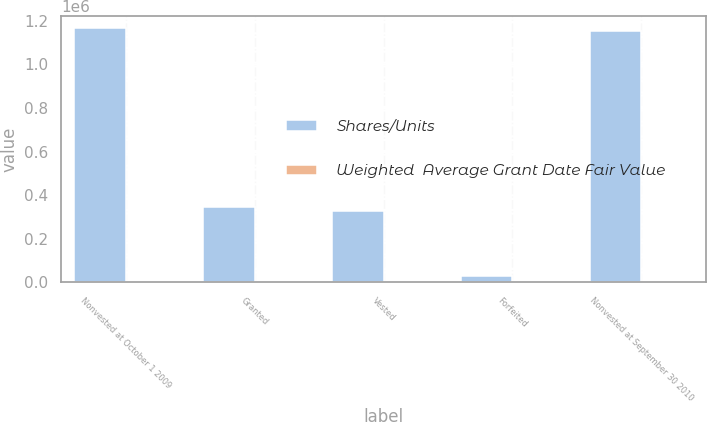Convert chart. <chart><loc_0><loc_0><loc_500><loc_500><stacked_bar_chart><ecel><fcel>Nonvested at October 1 2009<fcel>Granted<fcel>Vested<fcel>Forfeited<fcel>Nonvested at September 30 2010<nl><fcel>Shares/Units<fcel>1.16546e+06<fcel>346550<fcel>327286<fcel>30333<fcel>1.15439e+06<nl><fcel>Weighted  Average Grant Date Fair Value<fcel>26.8<fcel>23.59<fcel>30.93<fcel>26.14<fcel>24.68<nl></chart> 